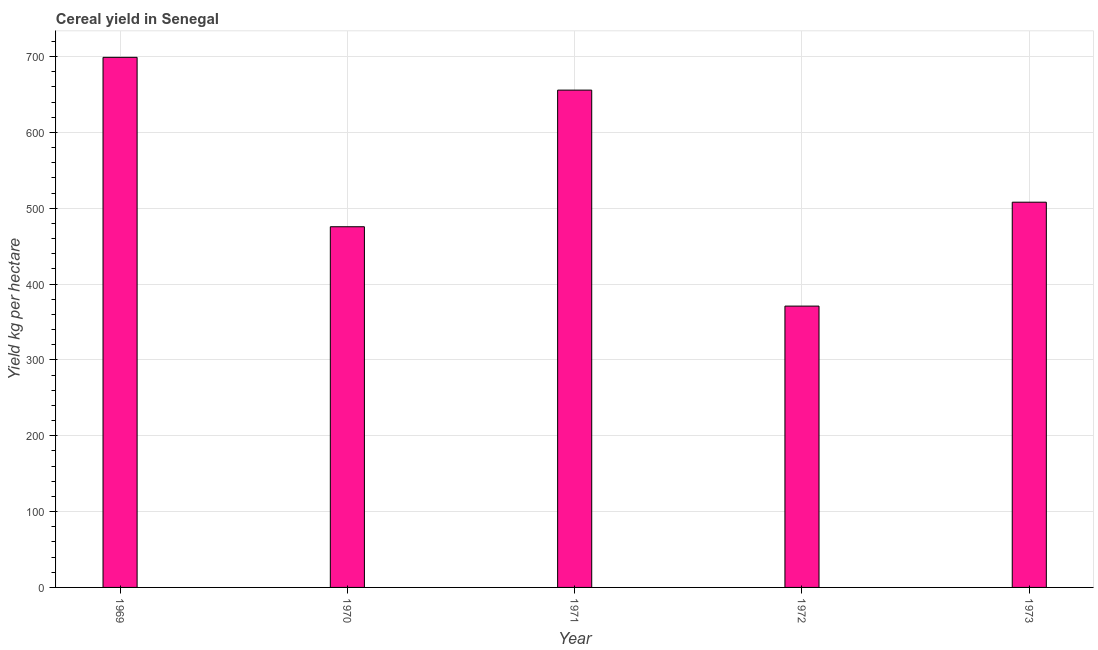Does the graph contain grids?
Give a very brief answer. Yes. What is the title of the graph?
Provide a succinct answer. Cereal yield in Senegal. What is the label or title of the Y-axis?
Provide a short and direct response. Yield kg per hectare. What is the cereal yield in 1970?
Give a very brief answer. 475.59. Across all years, what is the maximum cereal yield?
Your answer should be compact. 698.99. Across all years, what is the minimum cereal yield?
Give a very brief answer. 370.95. In which year was the cereal yield maximum?
Your response must be concise. 1969. In which year was the cereal yield minimum?
Keep it short and to the point. 1972. What is the sum of the cereal yield?
Make the answer very short. 2709.23. What is the difference between the cereal yield in 1969 and 1971?
Give a very brief answer. 43.24. What is the average cereal yield per year?
Your answer should be compact. 541.85. What is the median cereal yield?
Your response must be concise. 507.96. Do a majority of the years between 1972 and 1971 (inclusive) have cereal yield greater than 120 kg per hectare?
Offer a terse response. No. What is the ratio of the cereal yield in 1969 to that in 1973?
Your answer should be compact. 1.38. Is the cereal yield in 1970 less than that in 1971?
Your response must be concise. Yes. Is the difference between the cereal yield in 1971 and 1972 greater than the difference between any two years?
Offer a terse response. No. What is the difference between the highest and the second highest cereal yield?
Your answer should be compact. 43.24. Is the sum of the cereal yield in 1970 and 1971 greater than the maximum cereal yield across all years?
Provide a succinct answer. Yes. What is the difference between the highest and the lowest cereal yield?
Offer a terse response. 328.04. Are all the bars in the graph horizontal?
Your response must be concise. No. What is the difference between two consecutive major ticks on the Y-axis?
Ensure brevity in your answer.  100. Are the values on the major ticks of Y-axis written in scientific E-notation?
Give a very brief answer. No. What is the Yield kg per hectare in 1969?
Provide a succinct answer. 698.99. What is the Yield kg per hectare in 1970?
Ensure brevity in your answer.  475.59. What is the Yield kg per hectare in 1971?
Provide a short and direct response. 655.74. What is the Yield kg per hectare of 1972?
Make the answer very short. 370.95. What is the Yield kg per hectare of 1973?
Provide a succinct answer. 507.96. What is the difference between the Yield kg per hectare in 1969 and 1970?
Provide a succinct answer. 223.4. What is the difference between the Yield kg per hectare in 1969 and 1971?
Your answer should be compact. 43.24. What is the difference between the Yield kg per hectare in 1969 and 1972?
Your answer should be very brief. 328.04. What is the difference between the Yield kg per hectare in 1969 and 1973?
Make the answer very short. 191.02. What is the difference between the Yield kg per hectare in 1970 and 1971?
Your response must be concise. -180.16. What is the difference between the Yield kg per hectare in 1970 and 1972?
Make the answer very short. 104.64. What is the difference between the Yield kg per hectare in 1970 and 1973?
Keep it short and to the point. -32.37. What is the difference between the Yield kg per hectare in 1971 and 1972?
Your response must be concise. 284.8. What is the difference between the Yield kg per hectare in 1971 and 1973?
Keep it short and to the point. 147.78. What is the difference between the Yield kg per hectare in 1972 and 1973?
Give a very brief answer. -137.02. What is the ratio of the Yield kg per hectare in 1969 to that in 1970?
Offer a terse response. 1.47. What is the ratio of the Yield kg per hectare in 1969 to that in 1971?
Make the answer very short. 1.07. What is the ratio of the Yield kg per hectare in 1969 to that in 1972?
Provide a short and direct response. 1.88. What is the ratio of the Yield kg per hectare in 1969 to that in 1973?
Offer a terse response. 1.38. What is the ratio of the Yield kg per hectare in 1970 to that in 1971?
Your answer should be compact. 0.72. What is the ratio of the Yield kg per hectare in 1970 to that in 1972?
Provide a short and direct response. 1.28. What is the ratio of the Yield kg per hectare in 1970 to that in 1973?
Offer a very short reply. 0.94. What is the ratio of the Yield kg per hectare in 1971 to that in 1972?
Your response must be concise. 1.77. What is the ratio of the Yield kg per hectare in 1971 to that in 1973?
Keep it short and to the point. 1.29. What is the ratio of the Yield kg per hectare in 1972 to that in 1973?
Offer a very short reply. 0.73. 